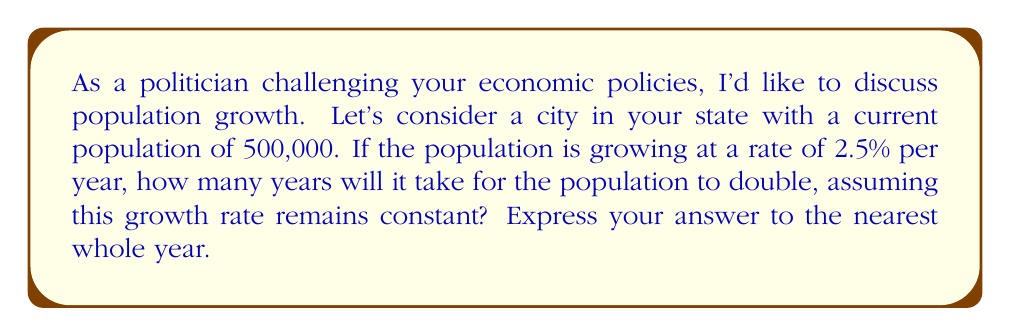What is the answer to this math problem? To solve this problem, we'll use the exponential growth formula and the concept of doubling time.

1) The exponential growth formula is:

   $$P(t) = P_0 \cdot e^{rt}$$

   Where:
   $P(t)$ is the population at time $t$
   $P_0$ is the initial population
   $r$ is the growth rate (as a decimal)
   $t$ is the time in years

2) We want to find when the population doubles, so:

   $$2P_0 = P_0 \cdot e^{rt}$$

3) Divide both sides by $P_0$:

   $$2 = e^{rt}$$

4) Take the natural log of both sides:

   $$\ln(2) = rt$$

5) Solve for $t$:

   $$t = \frac{\ln(2)}{r}$$

6) Now, let's plug in our growth rate. Remember to convert the percentage to a decimal:

   $$t = \frac{\ln(2)}{0.025} \approx 27.7259$$

7) Rounding to the nearest whole year:

   $$t \approx 28 \text{ years}$$

This formula, $t = \frac{\ln(2)}{r}$, is known as the "doubling time" formula for exponential growth.
Answer: 28 years 